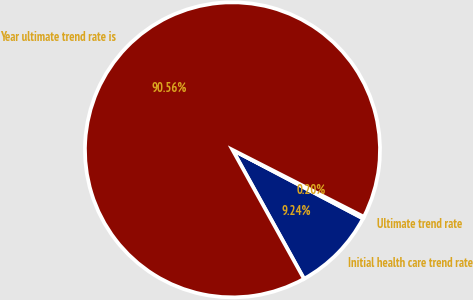Convert chart. <chart><loc_0><loc_0><loc_500><loc_500><pie_chart><fcel>Initial health care trend rate<fcel>Ultimate trend rate<fcel>Year ultimate trend rate is<nl><fcel>9.24%<fcel>0.2%<fcel>90.56%<nl></chart> 